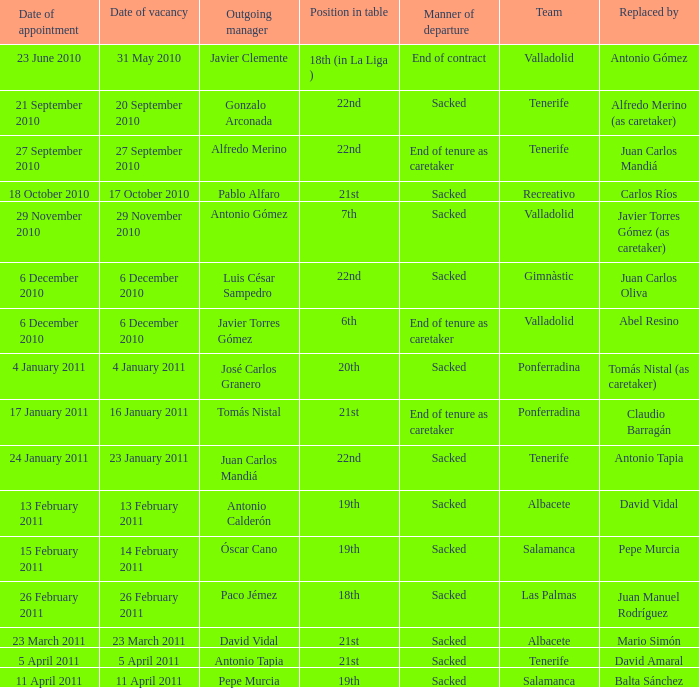What is the role for the departing manager alfredo merino? 22nd. 